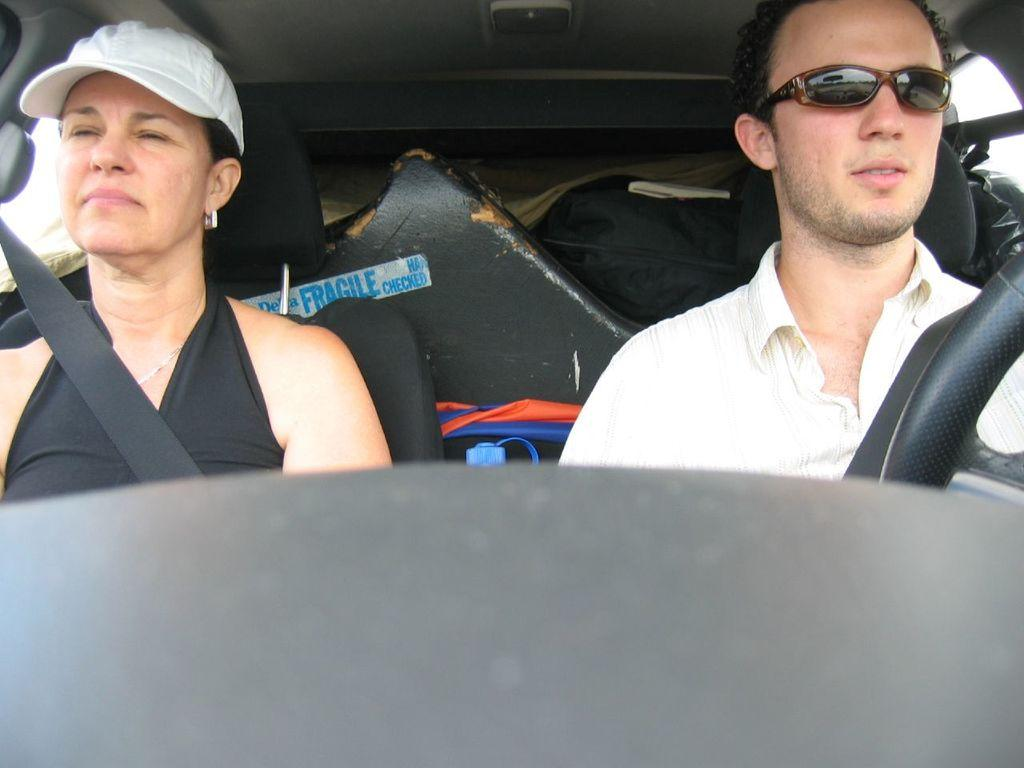Where was the image taken? The image was taken inside a car. How many people are in the car? There are two persons sitting in the car. What can be seen in the background of the image? There is a black color board in the background of the image. Can you see any sheep in the image? There are no sheep present in the image; it was taken inside a car. What arithmetic problem is being solved on the color board in the image? There is no arithmetic problem visible on the color board in the image. 